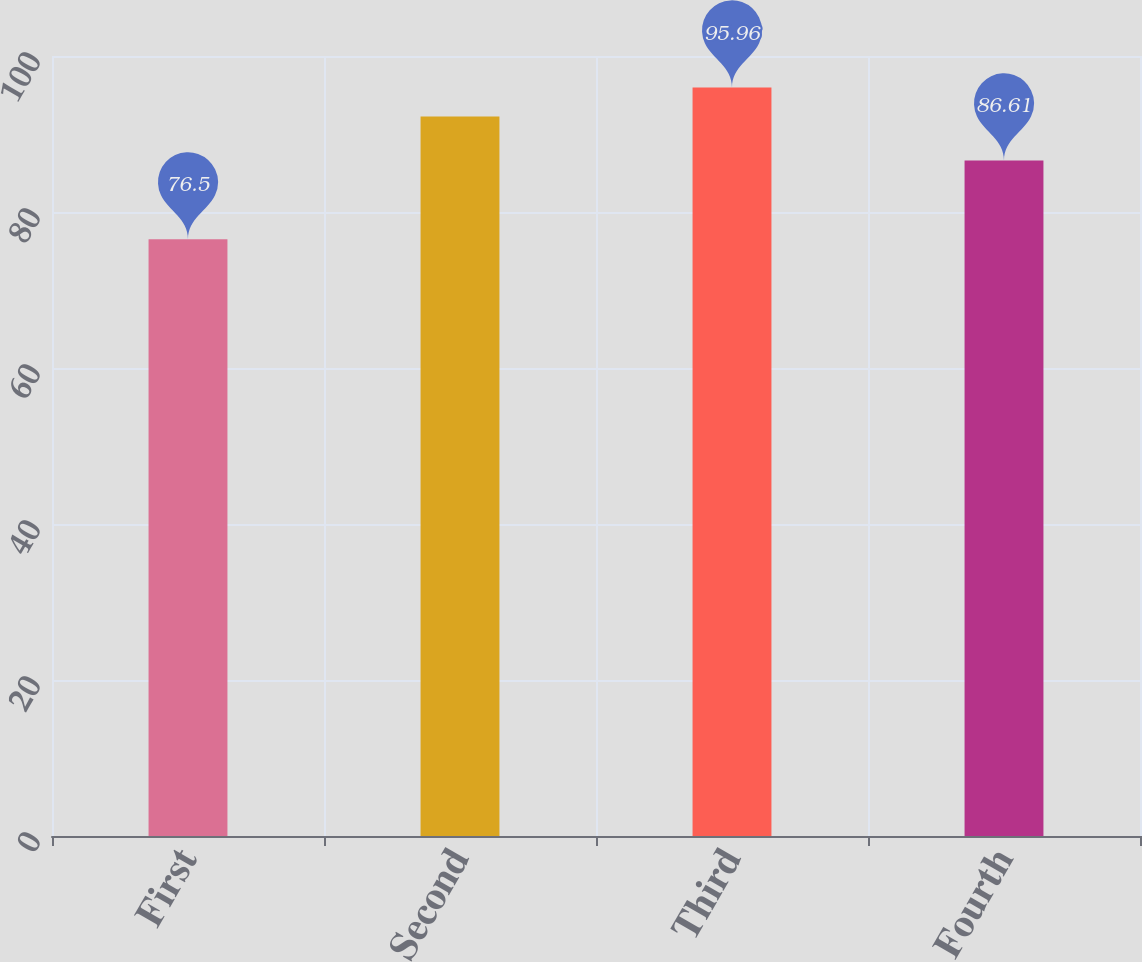Convert chart. <chart><loc_0><loc_0><loc_500><loc_500><bar_chart><fcel>First<fcel>Second<fcel>Third<fcel>Fourth<nl><fcel>76.5<fcel>92.25<fcel>95.96<fcel>86.61<nl></chart> 